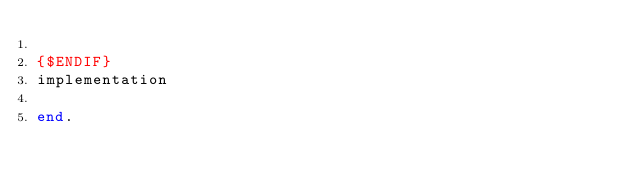<code> <loc_0><loc_0><loc_500><loc_500><_Pascal_>
{$ENDIF}
implementation

end.

</code> 